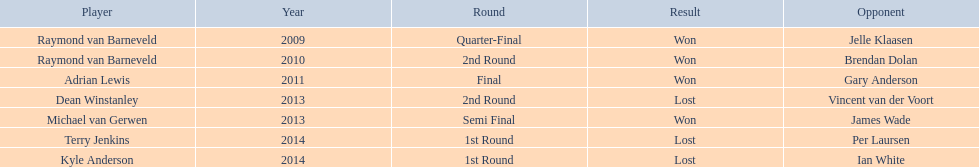In 2014, was terry jenkins the winner? Terry Jenkins, Lost. If not, who claimed victory? Per Laursen. 